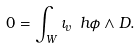Convert formula to latex. <formula><loc_0><loc_0><loc_500><loc_500>0 = \int _ { W } \iota _ { v } \ h \phi \wedge D .</formula> 